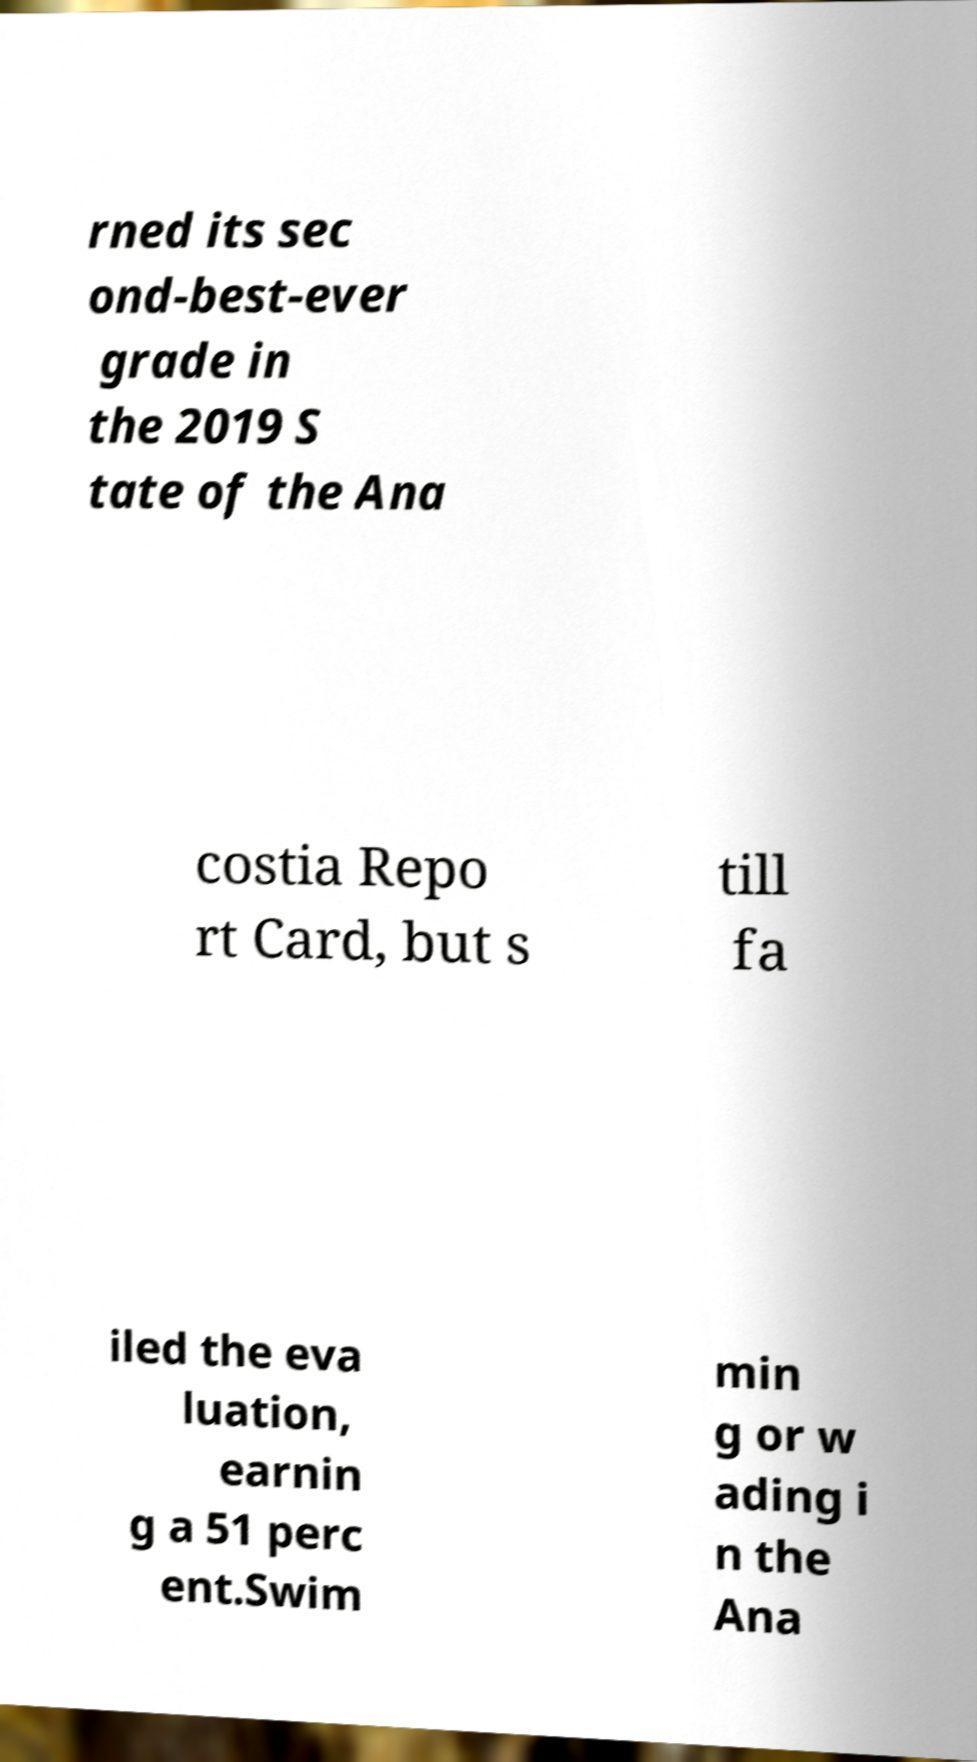Could you assist in decoding the text presented in this image and type it out clearly? rned its sec ond-best-ever grade in the 2019 S tate of the Ana costia Repo rt Card, but s till fa iled the eva luation, earnin g a 51 perc ent.Swim min g or w ading i n the Ana 